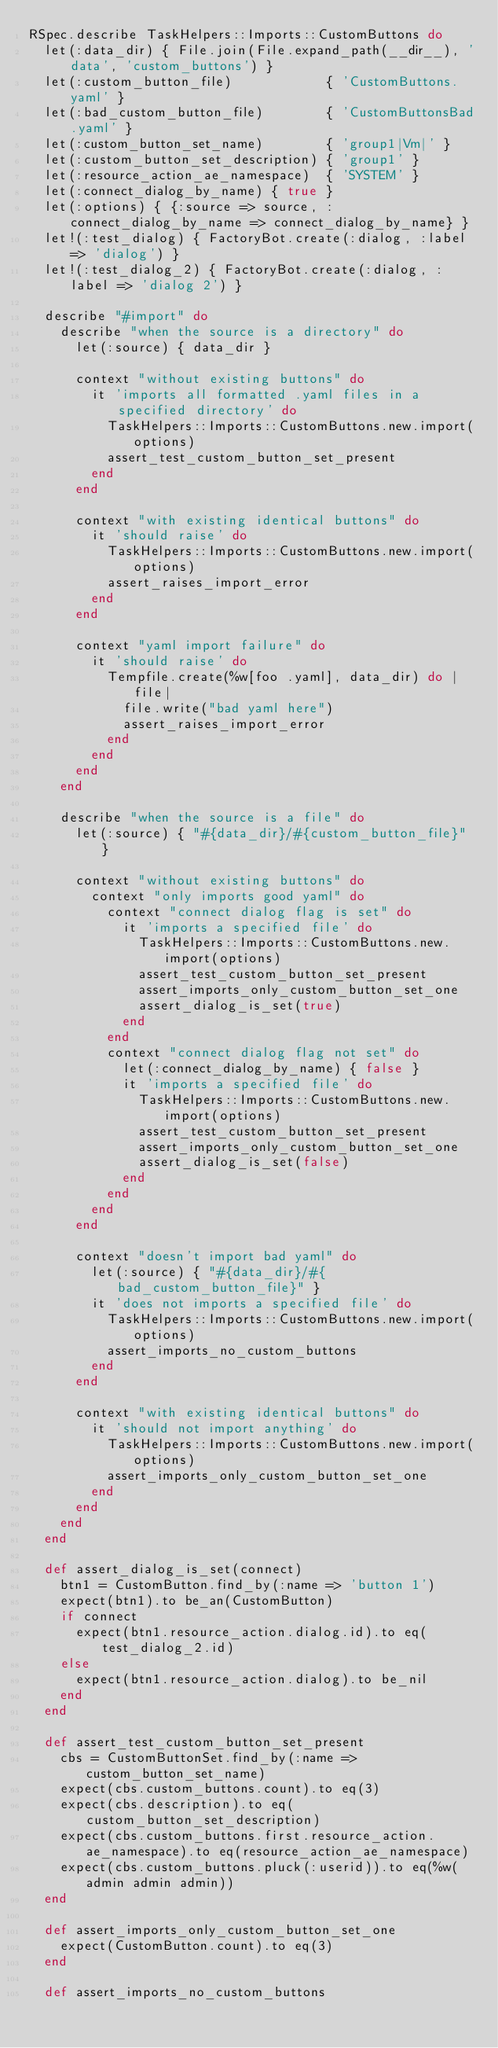<code> <loc_0><loc_0><loc_500><loc_500><_Ruby_>RSpec.describe TaskHelpers::Imports::CustomButtons do
  let(:data_dir) { File.join(File.expand_path(__dir__), 'data', 'custom_buttons') }
  let(:custom_button_file)            { 'CustomButtons.yaml' }
  let(:bad_custom_button_file)        { 'CustomButtonsBad.yaml' }
  let(:custom_button_set_name)        { 'group1|Vm|' }
  let(:custom_button_set_description) { 'group1' }
  let(:resource_action_ae_namespace)  { 'SYSTEM' }
  let(:connect_dialog_by_name) { true }
  let(:options) { {:source => source, :connect_dialog_by_name => connect_dialog_by_name} }
  let!(:test_dialog) { FactoryBot.create(:dialog, :label => 'dialog') }
  let!(:test_dialog_2) { FactoryBot.create(:dialog, :label => 'dialog 2') }

  describe "#import" do
    describe "when the source is a directory" do
      let(:source) { data_dir }

      context "without existing buttons" do
        it 'imports all formatted .yaml files in a specified directory' do
          TaskHelpers::Imports::CustomButtons.new.import(options)
          assert_test_custom_button_set_present
        end
      end

      context "with existing identical buttons" do
        it 'should raise' do
          TaskHelpers::Imports::CustomButtons.new.import(options)
          assert_raises_import_error
        end
      end

      context "yaml import failure" do
        it 'should raise' do
          Tempfile.create(%w[foo .yaml], data_dir) do |file|
            file.write("bad yaml here")
            assert_raises_import_error
          end
        end
      end
    end

    describe "when the source is a file" do
      let(:source) { "#{data_dir}/#{custom_button_file}" }

      context "without existing buttons" do
        context "only imports good yaml" do
          context "connect dialog flag is set" do
            it 'imports a specified file' do
              TaskHelpers::Imports::CustomButtons.new.import(options)
              assert_test_custom_button_set_present
              assert_imports_only_custom_button_set_one
              assert_dialog_is_set(true)
            end
          end
          context "connect dialog flag not set" do
            let(:connect_dialog_by_name) { false }
            it 'imports a specified file' do
              TaskHelpers::Imports::CustomButtons.new.import(options)
              assert_test_custom_button_set_present
              assert_imports_only_custom_button_set_one
              assert_dialog_is_set(false)
            end
          end
        end
      end

      context "doesn't import bad yaml" do
        let(:source) { "#{data_dir}/#{bad_custom_button_file}" }
        it 'does not imports a specified file' do
          TaskHelpers::Imports::CustomButtons.new.import(options)
          assert_imports_no_custom_buttons
        end
      end

      context "with existing identical buttons" do
        it 'should not import anything' do
          TaskHelpers::Imports::CustomButtons.new.import(options)
          assert_imports_only_custom_button_set_one
        end
      end
    end
  end

  def assert_dialog_is_set(connect)
    btn1 = CustomButton.find_by(:name => 'button 1')
    expect(btn1).to be_an(CustomButton)
    if connect
      expect(btn1.resource_action.dialog.id).to eq(test_dialog_2.id)
    else
      expect(btn1.resource_action.dialog).to be_nil
    end
  end

  def assert_test_custom_button_set_present
    cbs = CustomButtonSet.find_by(:name => custom_button_set_name)
    expect(cbs.custom_buttons.count).to eq(3)
    expect(cbs.description).to eq(custom_button_set_description)
    expect(cbs.custom_buttons.first.resource_action.ae_namespace).to eq(resource_action_ae_namespace)
    expect(cbs.custom_buttons.pluck(:userid)).to eq(%w(admin admin admin))
  end

  def assert_imports_only_custom_button_set_one
    expect(CustomButton.count).to eq(3)
  end

  def assert_imports_no_custom_buttons</code> 